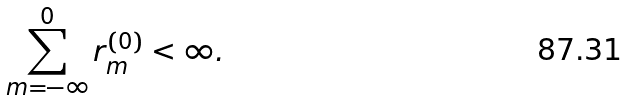Convert formula to latex. <formula><loc_0><loc_0><loc_500><loc_500>\sum _ { m = - \infty } ^ { 0 } r _ { m } ^ { ( 0 ) } < \infty .</formula> 